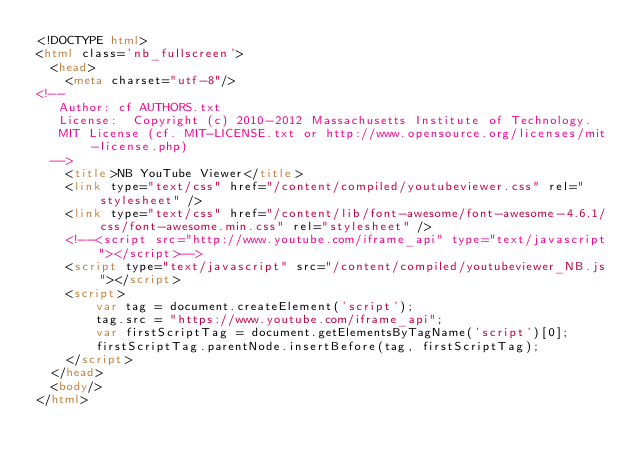<code> <loc_0><loc_0><loc_500><loc_500><_HTML_><!DOCTYPE html>
<html class='nb_fullscreen'>
  <head>
    <meta charset="utf-8"/>
<!--
   Author: cf AUTHORS.txt 
   License:  Copyright (c) 2010-2012 Massachusetts Institute of Technology.
   MIT License (cf. MIT-LICENSE.txt or http://www.opensource.org/licenses/mit-license.php)
  -->
    <title>NB YouTube Viewer</title>
    <link type="text/css" href="/content/compiled/youtubeviewer.css" rel="stylesheet" />
    <link type="text/css" href="/content/lib/font-awesome/font-awesome-4.6.1/css/font-awesome.min.css" rel="stylesheet" />
    <!--<script src="http://www.youtube.com/iframe_api" type="text/javascript"></script>-->
    <script type="text/javascript" src="/content/compiled/youtubeviewer_NB.js"></script>
    <script>
        var tag = document.createElement('script');
        tag.src = "https://www.youtube.com/iframe_api";
        var firstScriptTag = document.getElementsByTagName('script')[0];
        firstScriptTag.parentNode.insertBefore(tag, firstScriptTag);
    </script>
  </head>
  <body/>
</html>

</code> 